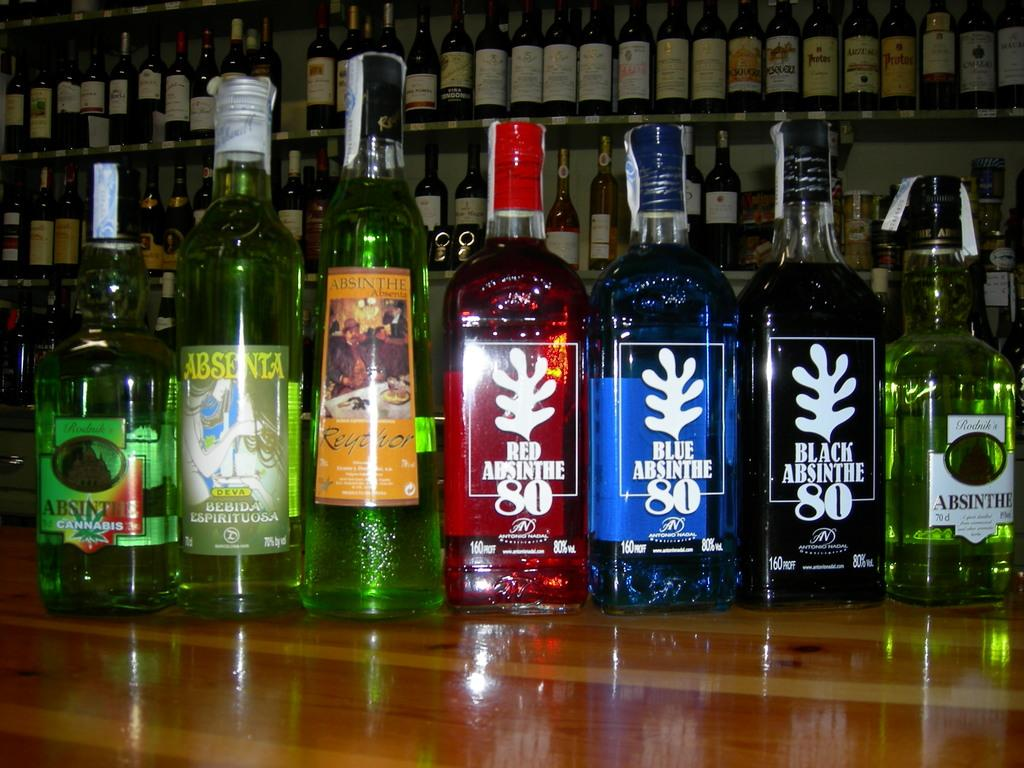What objects are on the wooden table in the image? There is a group of bottles on a wooden table in the image. What can be seen in the background of the image? The background of the image contains a shelf filled with wine bottles. How many spiders are crawling on the bottles in the image? There are no spiders present in the image; it only features a group of bottles on a wooden table and a shelf filled with wine bottles in the background. 